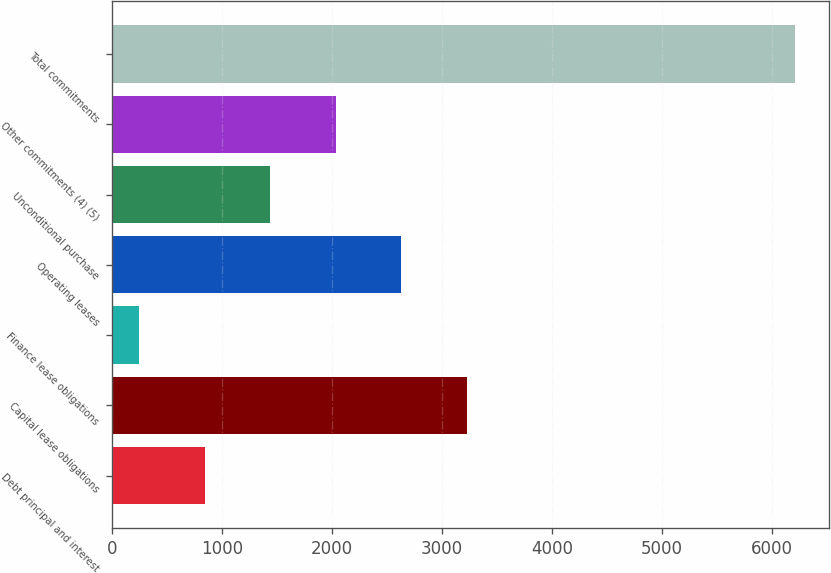<chart> <loc_0><loc_0><loc_500><loc_500><bar_chart><fcel>Debt principal and interest<fcel>Capital lease obligations<fcel>Finance lease obligations<fcel>Operating leases<fcel>Unconditional purchase<fcel>Other commitments (4) (5)<fcel>Total commitments<nl><fcel>840.5<fcel>3226.5<fcel>244<fcel>2630<fcel>1437<fcel>2033.5<fcel>6209<nl></chart> 